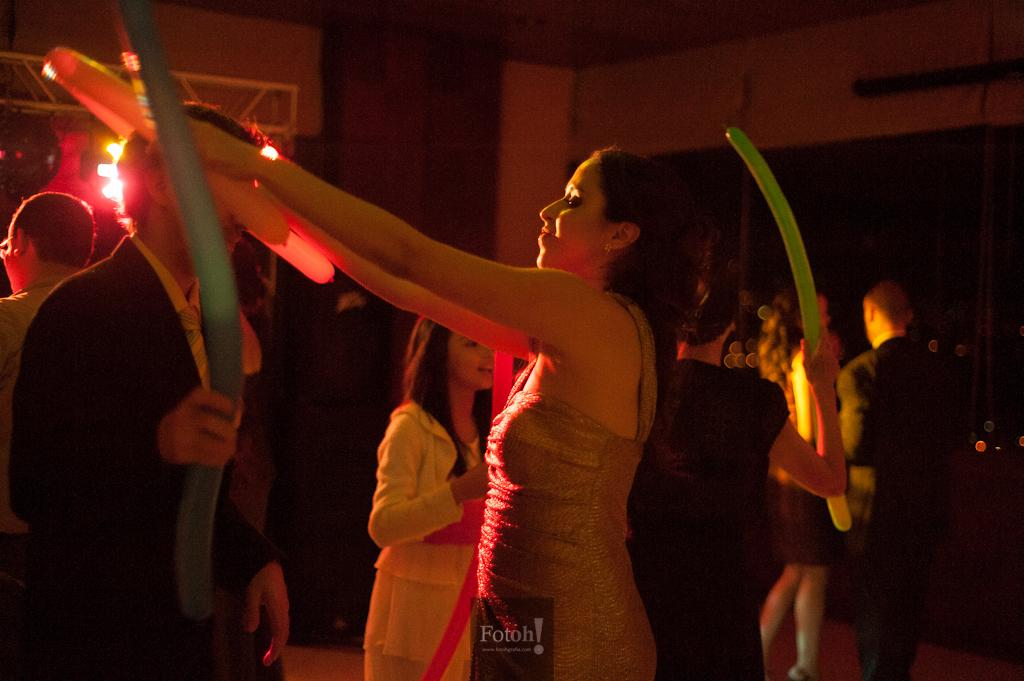How many people are in the group that is visible in the image? There is a group of people in the image, but the exact number is not specified. What are some people in the group holding? Some people in the group are holding balloons. What can be seen in the background of the image? There are lights and objects visible in the background of the image. What type of blood is visible on the dinosaurs in the image? There are no dinosaurs or blood present in the image. 